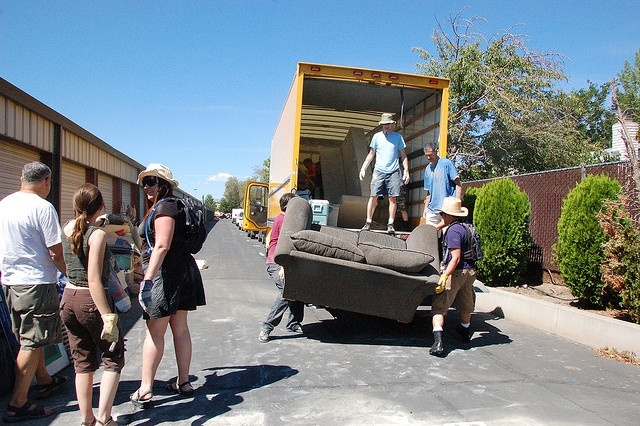Describe the objects in this image and their specific colors. I can see truck in lightblue, black, darkgray, gray, and maroon tones, couch in lightblue, black, darkgray, and gray tones, people in lightblue, white, black, darkgray, and maroon tones, people in lightblue, black, gray, lightgray, and brown tones, and people in lightblue, black, gray, and ivory tones in this image. 